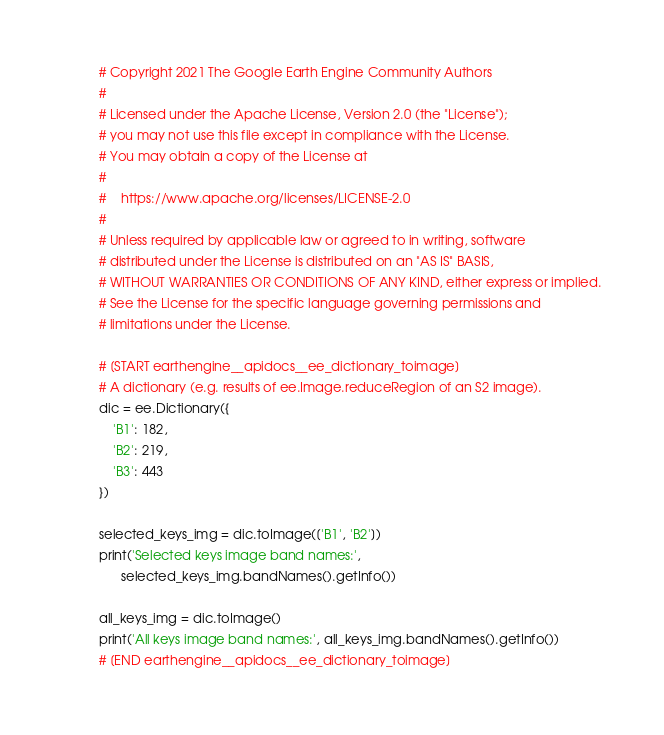Convert code to text. <code><loc_0><loc_0><loc_500><loc_500><_Python_># Copyright 2021 The Google Earth Engine Community Authors
#
# Licensed under the Apache License, Version 2.0 (the "License");
# you may not use this file except in compliance with the License.
# You may obtain a copy of the License at
#
#    https://www.apache.org/licenses/LICENSE-2.0
#
# Unless required by applicable law or agreed to in writing, software
# distributed under the License is distributed on an "AS IS" BASIS,
# WITHOUT WARRANTIES OR CONDITIONS OF ANY KIND, either express or implied.
# See the License for the specific language governing permissions and
# limitations under the License.

# [START earthengine__apidocs__ee_dictionary_toimage]
# A dictionary (e.g. results of ee.Image.reduceRegion of an S2 image).
dic = ee.Dictionary({
    'B1': 182,
    'B2': 219,
    'B3': 443
})

selected_keys_img = dic.toImage(['B1', 'B2'])
print('Selected keys image band names:',
      selected_keys_img.bandNames().getInfo())

all_keys_img = dic.toImage()
print('All keys image band names:', all_keys_img.bandNames().getInfo())
# [END earthengine__apidocs__ee_dictionary_toimage]
</code> 